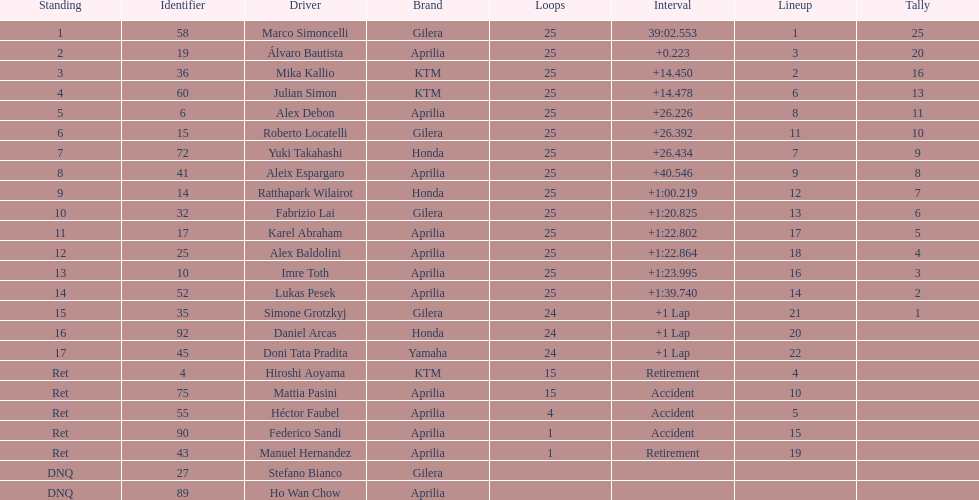What is the total number of laps performed by rider imre toth? 25. 